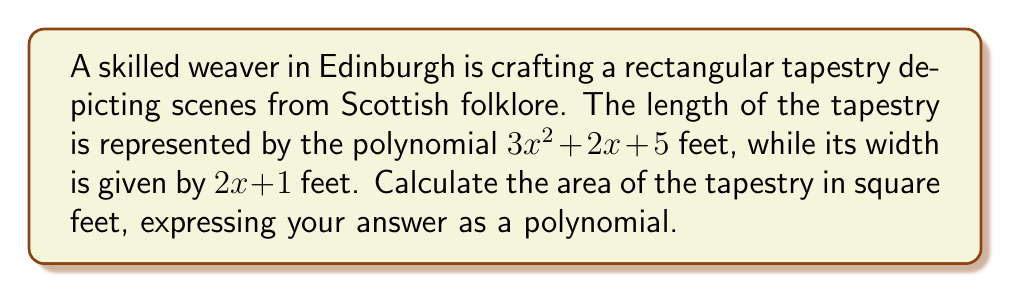Teach me how to tackle this problem. To calculate the area of the rectangular tapestry, we need to multiply its length by its width. Let's approach this step-by-step:

1) The length of the tapestry is: $3x^2 + 2x + 5$ feet
   The width of the tapestry is: $2x + 1$ feet

2) Area = Length × Width
   $$A = (3x^2 + 2x + 5)(2x + 1)$$

3) To multiply these polynomials, we need to use the distributive property:
   $$A = 3x^2(2x + 1) + 2x(2x + 1) + 5(2x + 1)$$

4) Let's expand each term:
   $$A = (6x^3 + 3x^2) + (4x^2 + 2x) + (10x + 5)$$

5) Now, we can combine like terms:
   $$A = 6x^3 + 7x^2 + 12x + 5$$

This polynomial represents the area of the tapestry in square feet.
Answer: $6x^3 + 7x^2 + 12x + 5$ square feet 